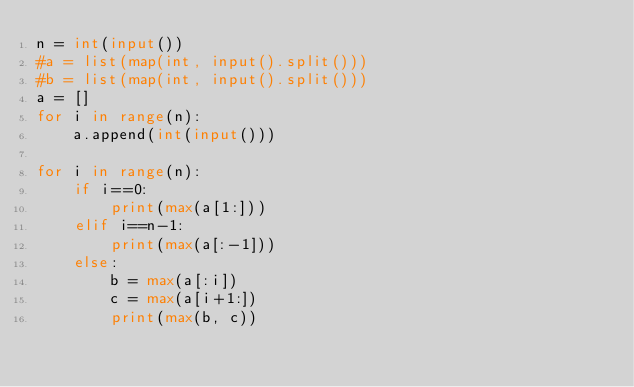<code> <loc_0><loc_0><loc_500><loc_500><_Python_>n = int(input())
#a = list(map(int, input().split()))
#b = list(map(int, input().split()))
a = []
for i in range(n):
    a.append(int(input()))

for i in range(n):
    if i==0:
        print(max(a[1:]))
    elif i==n-1:
        print(max(a[:-1]))
    else:
        b = max(a[:i])
        c = max(a[i+1:])
        print(max(b, c))</code> 